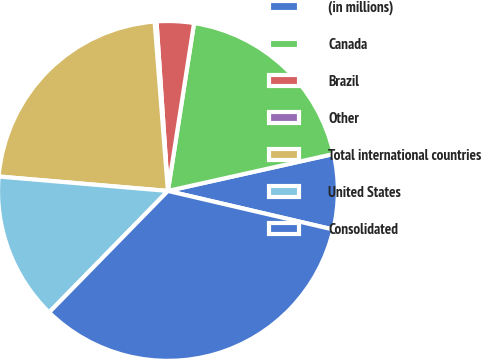Convert chart to OTSL. <chart><loc_0><loc_0><loc_500><loc_500><pie_chart><fcel>(in millions)<fcel>Canada<fcel>Brazil<fcel>Other<fcel>Total international countries<fcel>United States<fcel>Consolidated<nl><fcel>7.14%<fcel>19.05%<fcel>3.53%<fcel>0.18%<fcel>22.4%<fcel>14.03%<fcel>33.68%<nl></chart> 